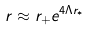Convert formula to latex. <formula><loc_0><loc_0><loc_500><loc_500>r \approx r _ { + } e ^ { 4 \Lambda r _ { * } }</formula> 